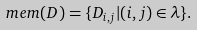Convert formula to latex. <formula><loc_0><loc_0><loc_500><loc_500>m e m ( D ) = \{ D _ { i , j } | ( i , j ) \in \lambda \} .</formula> 